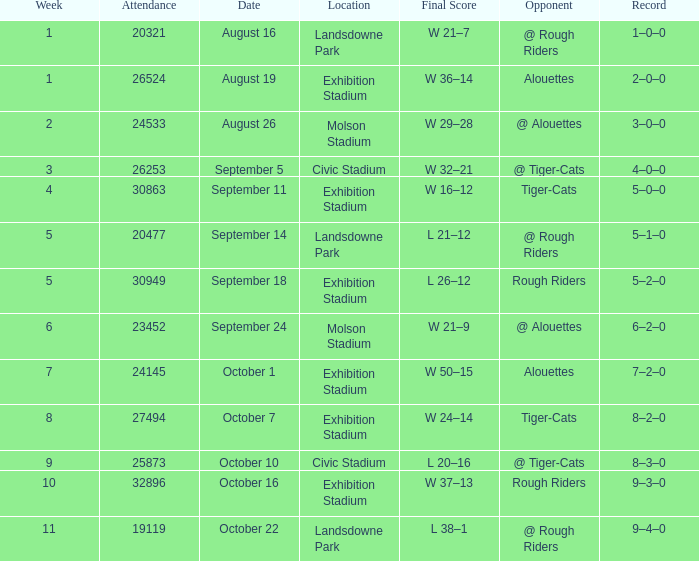How many values for attendance on the date of September 5? 1.0. 